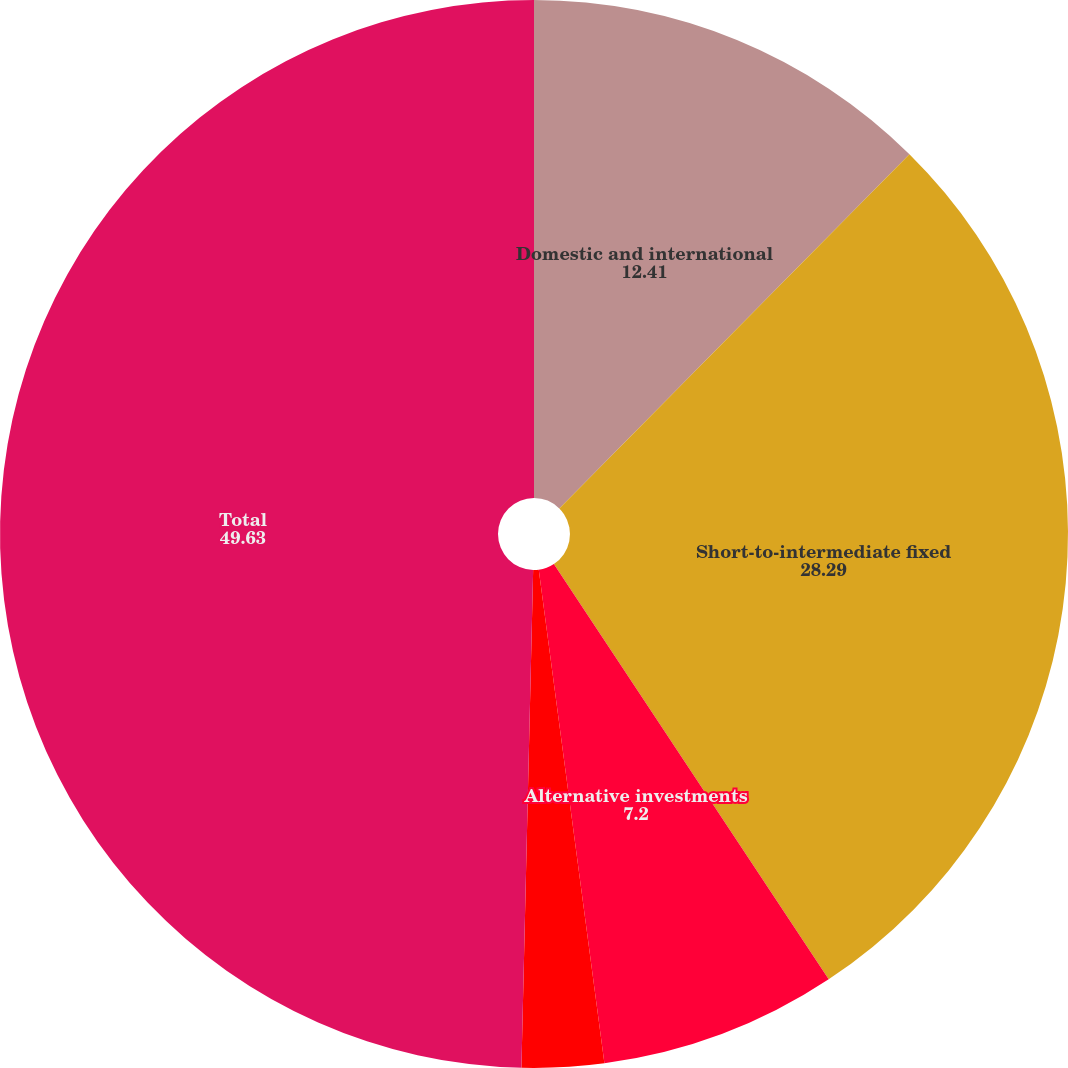Convert chart to OTSL. <chart><loc_0><loc_0><loc_500><loc_500><pie_chart><fcel>Domestic and international<fcel>Short-to-intermediate fixed<fcel>Alternative investments<fcel>Cash<fcel>Total<nl><fcel>12.41%<fcel>28.29%<fcel>7.2%<fcel>2.48%<fcel>49.63%<nl></chart> 